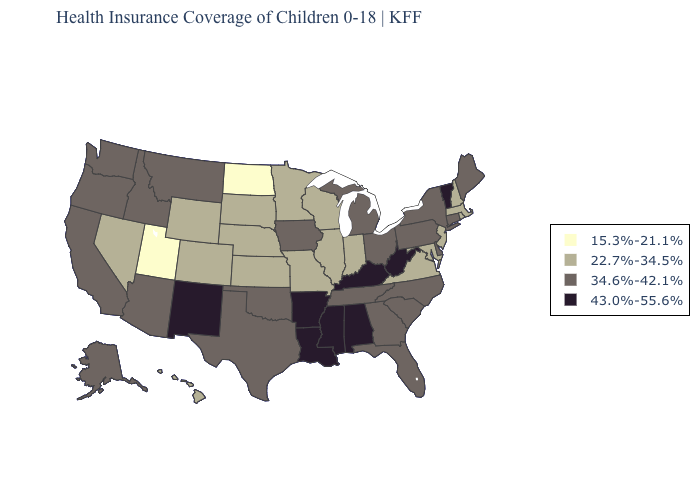Among the states that border New Mexico , does Utah have the highest value?
Give a very brief answer. No. Name the states that have a value in the range 22.7%-34.5%?
Keep it brief. Colorado, Hawaii, Illinois, Indiana, Kansas, Maryland, Massachusetts, Minnesota, Missouri, Nebraska, Nevada, New Hampshire, New Jersey, Rhode Island, South Dakota, Virginia, Wisconsin, Wyoming. Does the map have missing data?
Write a very short answer. No. What is the lowest value in the Northeast?
Concise answer only. 22.7%-34.5%. Among the states that border Florida , does Alabama have the lowest value?
Quick response, please. No. Is the legend a continuous bar?
Keep it brief. No. What is the highest value in the MidWest ?
Write a very short answer. 34.6%-42.1%. What is the value of Arkansas?
Answer briefly. 43.0%-55.6%. What is the lowest value in the MidWest?
Answer briefly. 15.3%-21.1%. Name the states that have a value in the range 15.3%-21.1%?
Be succinct. North Dakota, Utah. Name the states that have a value in the range 15.3%-21.1%?
Answer briefly. North Dakota, Utah. Name the states that have a value in the range 15.3%-21.1%?
Concise answer only. North Dakota, Utah. Which states have the lowest value in the Northeast?
Short answer required. Massachusetts, New Hampshire, New Jersey, Rhode Island. Name the states that have a value in the range 43.0%-55.6%?
Give a very brief answer. Alabama, Arkansas, Kentucky, Louisiana, Mississippi, New Mexico, Vermont, West Virginia. Name the states that have a value in the range 15.3%-21.1%?
Answer briefly. North Dakota, Utah. 